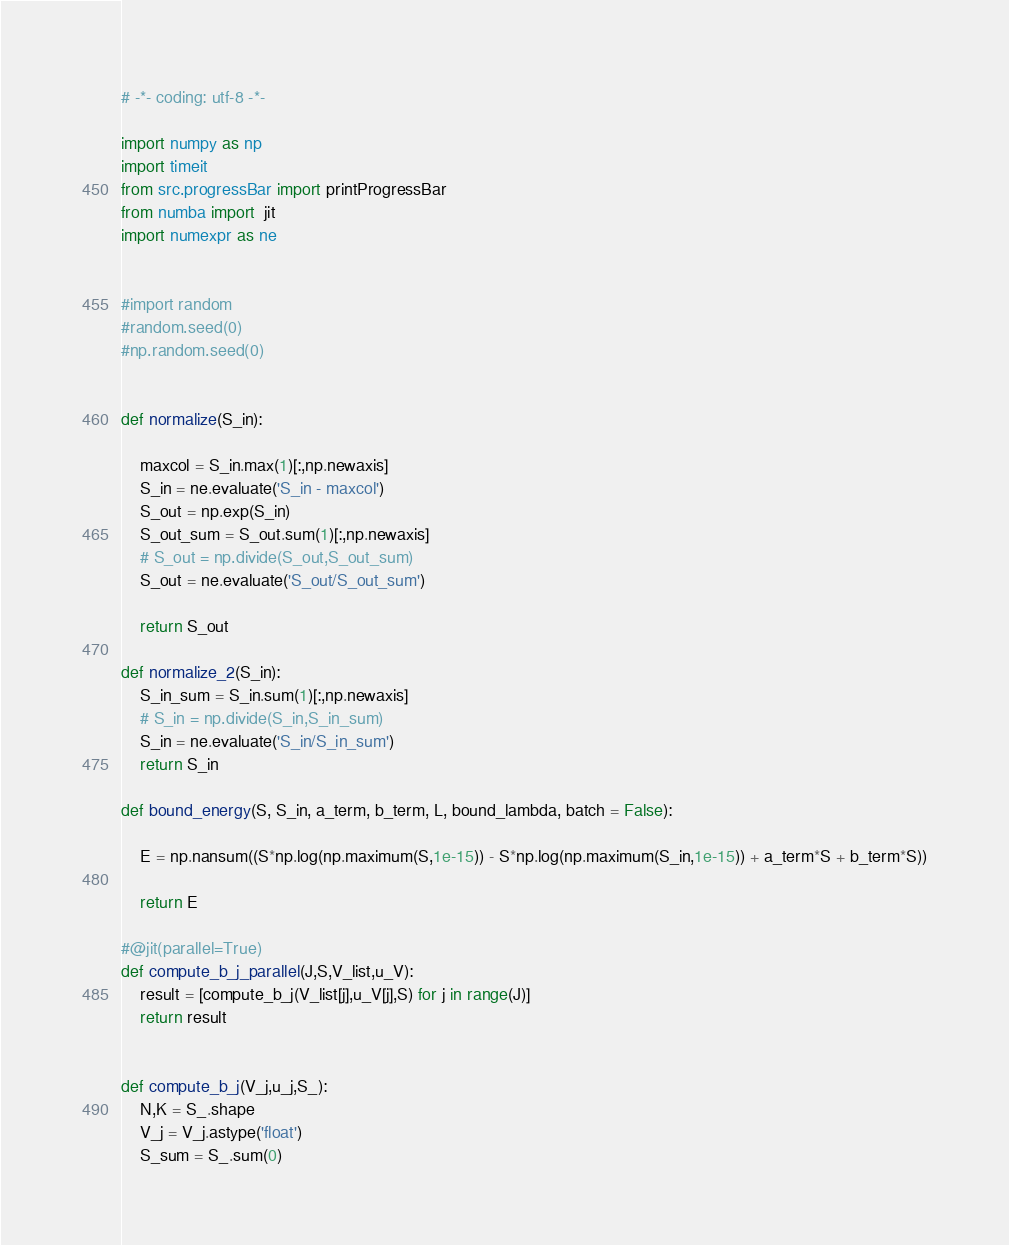Convert code to text. <code><loc_0><loc_0><loc_500><loc_500><_Python_># -*- coding: utf-8 -*-

import numpy as np
import timeit
from src.progressBar import printProgressBar
from numba import  jit
import numexpr as ne


#import random
#random.seed(0)
#np.random.seed(0)


def normalize(S_in):

    maxcol = S_in.max(1)[:,np.newaxis]
    S_in = ne.evaluate('S_in - maxcol')
    S_out = np.exp(S_in)
    S_out_sum = S_out.sum(1)[:,np.newaxis]
    # S_out = np.divide(S_out,S_out_sum)
    S_out = ne.evaluate('S_out/S_out_sum')
    
    return S_out

def normalize_2(S_in):
    S_in_sum = S_in.sum(1)[:,np.newaxis]
    # S_in = np.divide(S_in,S_in_sum)
    S_in = ne.evaluate('S_in/S_in_sum')
    return S_in

def bound_energy(S, S_in, a_term, b_term, L, bound_lambda, batch = False):

    E = np.nansum((S*np.log(np.maximum(S,1e-15)) - S*np.log(np.maximum(S_in,1e-15)) + a_term*S + b_term*S))

    return E

#@jit(parallel=True)
def compute_b_j_parallel(J,S,V_list,u_V):
    result = [compute_b_j(V_list[j],u_V[j],S) for j in range(J)]
    return result


def compute_b_j(V_j,u_j,S_):
    N,K = S_.shape
    V_j = V_j.astype('float')
    S_sum = S_.sum(0)</code> 